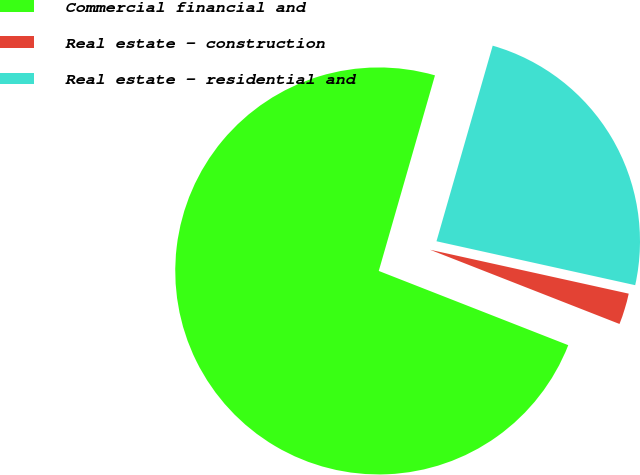Convert chart to OTSL. <chart><loc_0><loc_0><loc_500><loc_500><pie_chart><fcel>Commercial financial and<fcel>Real estate - construction<fcel>Real estate - residential and<nl><fcel>73.52%<fcel>2.48%<fcel>24.01%<nl></chart> 